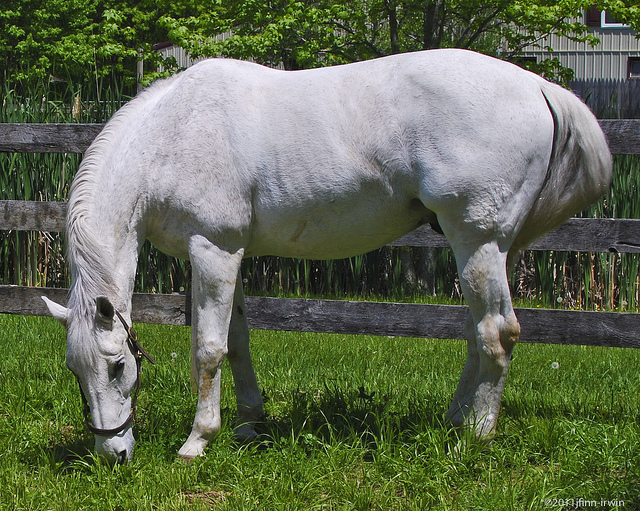What color is the fence that the horse is near? The fence near the horse is dark in color, possibly either a deep brown or black. 